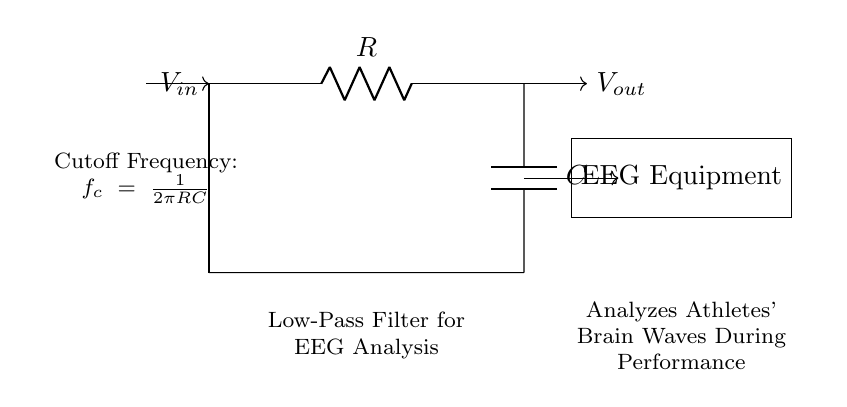What is the main function of this circuit? The main function of this circuit is to act as a low-pass filter, which allows signals of lower frequencies to pass while attenuating higher frequencies. This is important for analyzing EEG signals as it helps isolate relevant brain wave activity during performance.
Answer: Low-pass filter What are the components used in the circuit? The components used in the circuit are a resistor and a capacitor. These two components are critical for determining the behavior of the low-pass filter, specifically its cutoff frequency.
Answer: Resistor and capacitor What is the cutoff frequency formula given in the diagram? The cutoff frequency is expressed in the formula as \( f_c = \frac{1}{2\pi RC} \). This formula shows how the resistance and capacitance values influence the frequency at which the output voltage begins to decline.
Answer: \( f_c = \frac{1}{2\pi RC} \) If the resistance is doubled while capacitance remains the same, what happens to the cutoff frequency? If the resistance is doubled, the cutoff frequency will be halved. This is derived from the cutoff frequency formula, where increasing the resistor value \( R \) decreases the value of \( f_c \) since it is inversely proportional to \( R \).
Answer: Halved What does the output voltage represent in this circuit? The output voltage represents the filtered EEG signal after it has passed through the low-pass filter. It captures the lower frequency components of the brain waves, which are crucial for performance analysis.
Answer: Filtered EEG signal What is the significance of using a low-pass filter in EEG analysis for athletes? The significance of using a low-pass filter in EEG analysis for athletes is that it allows for a clearer interpretation of brain waves relevant to cognitive and emotional states, filtering out noise and higher frequency data that can interfere with analysis.
Answer: Clear interpretation of brain waves 